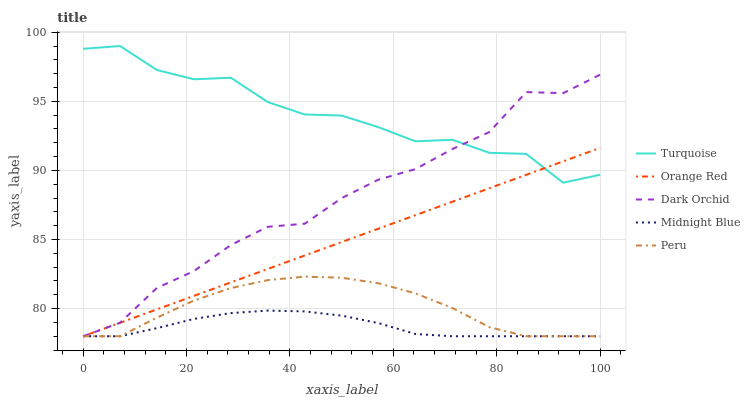Does Midnight Blue have the minimum area under the curve?
Answer yes or no. Yes. Does Turquoise have the maximum area under the curve?
Answer yes or no. Yes. Does Orange Red have the minimum area under the curve?
Answer yes or no. No. Does Orange Red have the maximum area under the curve?
Answer yes or no. No. Is Orange Red the smoothest?
Answer yes or no. Yes. Is Turquoise the roughest?
Answer yes or no. Yes. Is Turquoise the smoothest?
Answer yes or no. No. Is Orange Red the roughest?
Answer yes or no. No. Does Peru have the lowest value?
Answer yes or no. Yes. Does Turquoise have the lowest value?
Answer yes or no. No. Does Turquoise have the highest value?
Answer yes or no. Yes. Does Orange Red have the highest value?
Answer yes or no. No. Is Midnight Blue less than Turquoise?
Answer yes or no. Yes. Is Turquoise greater than Peru?
Answer yes or no. Yes. Does Turquoise intersect Dark Orchid?
Answer yes or no. Yes. Is Turquoise less than Dark Orchid?
Answer yes or no. No. Is Turquoise greater than Dark Orchid?
Answer yes or no. No. Does Midnight Blue intersect Turquoise?
Answer yes or no. No. 